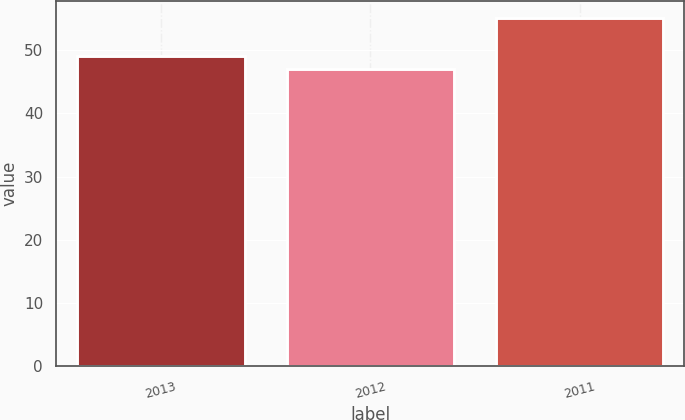<chart> <loc_0><loc_0><loc_500><loc_500><bar_chart><fcel>2013<fcel>2012<fcel>2011<nl><fcel>49<fcel>47<fcel>55<nl></chart> 